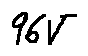<formula> <loc_0><loc_0><loc_500><loc_500>9 6 V</formula> 